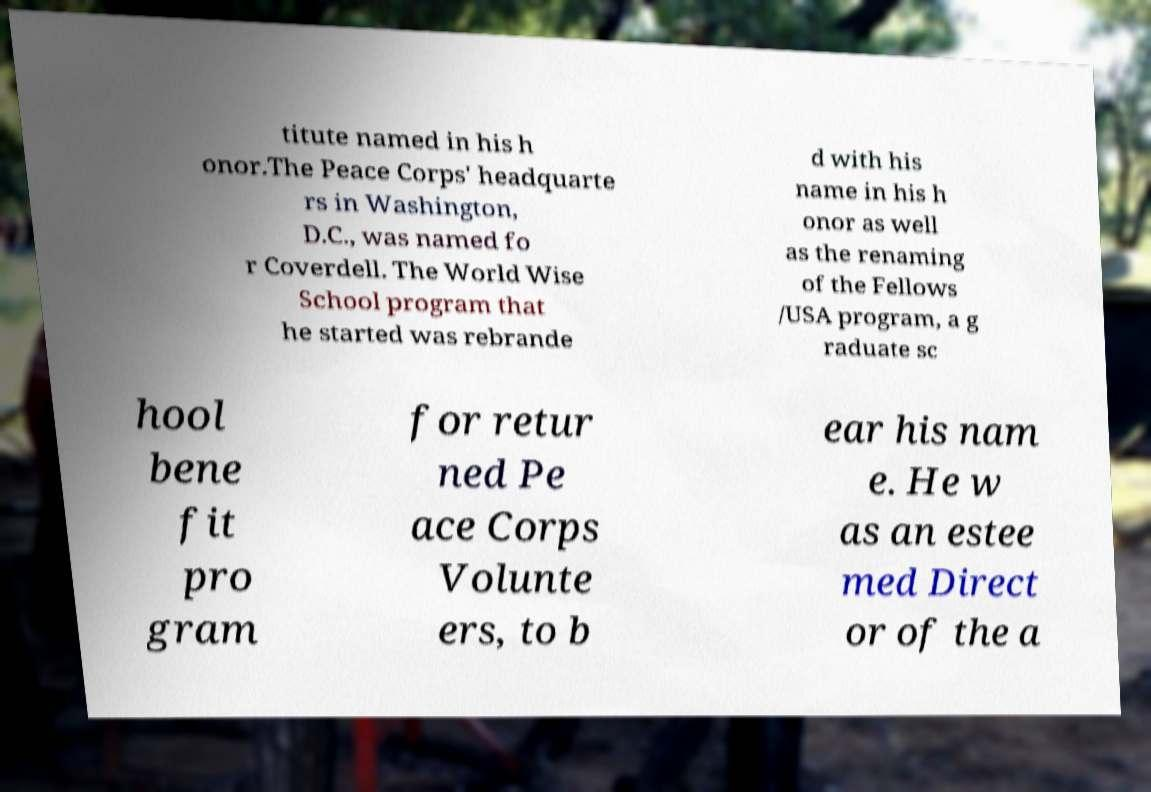There's text embedded in this image that I need extracted. Can you transcribe it verbatim? titute named in his h onor.The Peace Corps' headquarte rs in Washington, D.C., was named fo r Coverdell. The World Wise School program that he started was rebrande d with his name in his h onor as well as the renaming of the Fellows /USA program, a g raduate sc hool bene fit pro gram for retur ned Pe ace Corps Volunte ers, to b ear his nam e. He w as an estee med Direct or of the a 